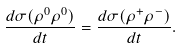<formula> <loc_0><loc_0><loc_500><loc_500>\frac { d \sigma ( \rho ^ { 0 } \rho ^ { 0 } ) } { d t } = \frac { d \sigma ( \rho ^ { + } \rho ^ { - } ) } { d t } .</formula> 